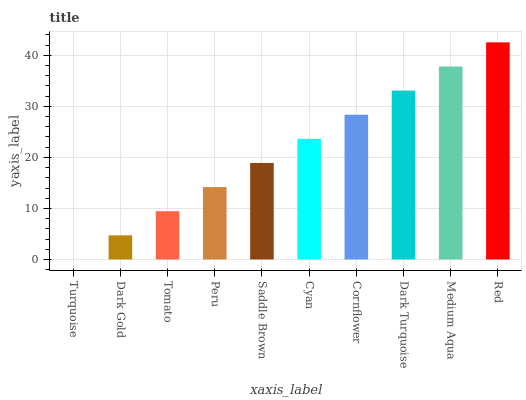Is Turquoise the minimum?
Answer yes or no. Yes. Is Red the maximum?
Answer yes or no. Yes. Is Dark Gold the minimum?
Answer yes or no. No. Is Dark Gold the maximum?
Answer yes or no. No. Is Dark Gold greater than Turquoise?
Answer yes or no. Yes. Is Turquoise less than Dark Gold?
Answer yes or no. Yes. Is Turquoise greater than Dark Gold?
Answer yes or no. No. Is Dark Gold less than Turquoise?
Answer yes or no. No. Is Cyan the high median?
Answer yes or no. Yes. Is Saddle Brown the low median?
Answer yes or no. Yes. Is Peru the high median?
Answer yes or no. No. Is Tomato the low median?
Answer yes or no. No. 